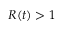<formula> <loc_0><loc_0><loc_500><loc_500>R ( t ) > 1</formula> 